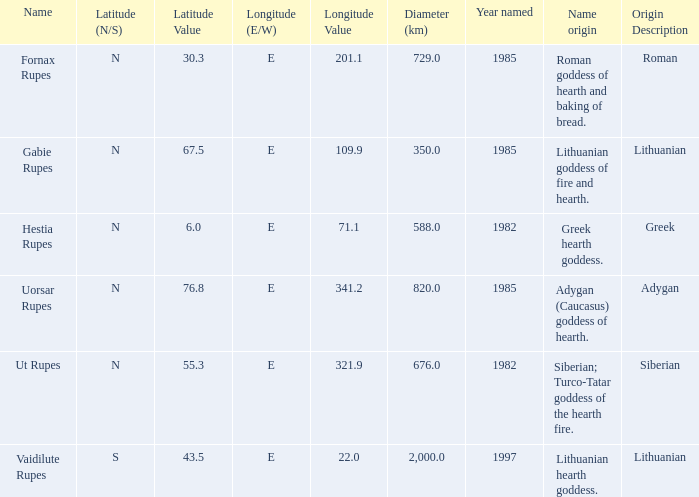At a longitude of 321.9e, what is the latitude of the features found? 55.3N. 